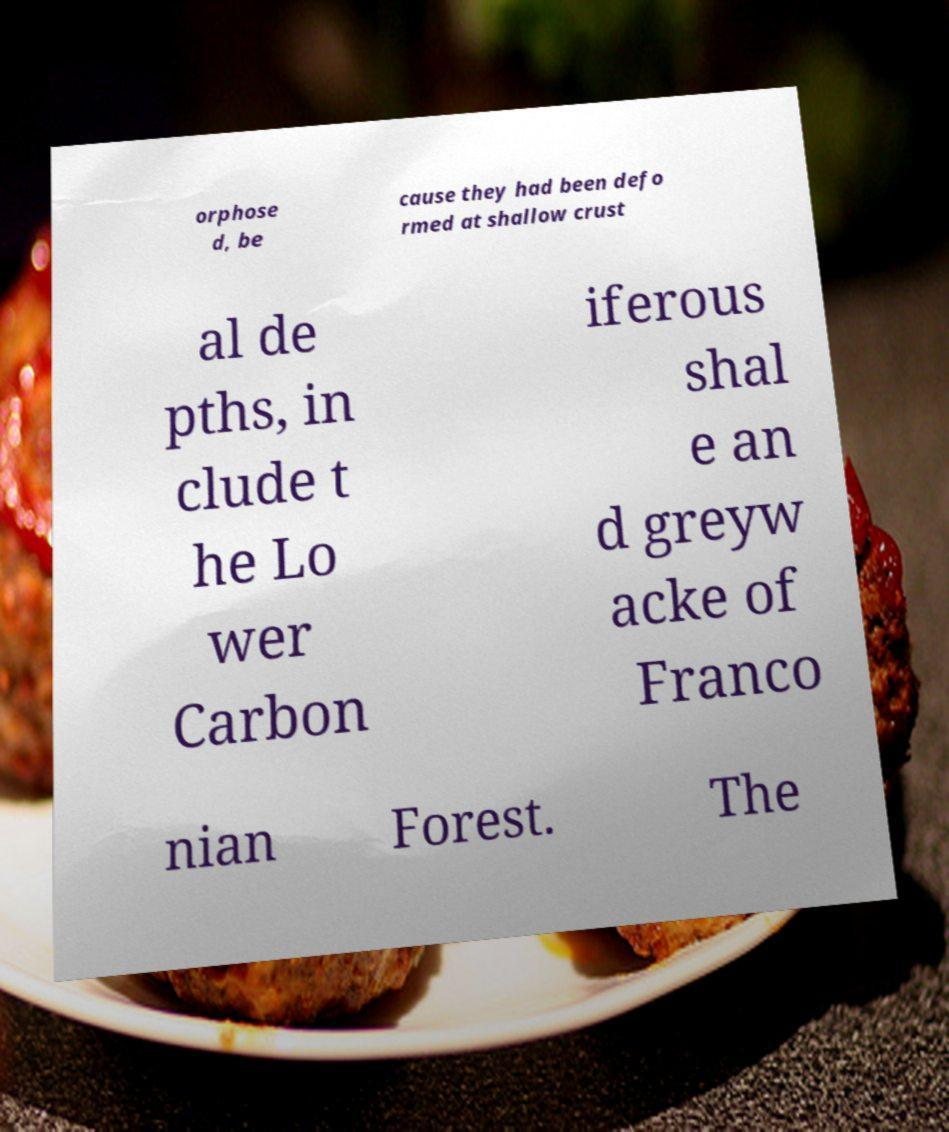What messages or text are displayed in this image? I need them in a readable, typed format. orphose d, be cause they had been defo rmed at shallow crust al de pths, in clude t he Lo wer Carbon iferous shal e an d greyw acke of Franco nian Forest. The 